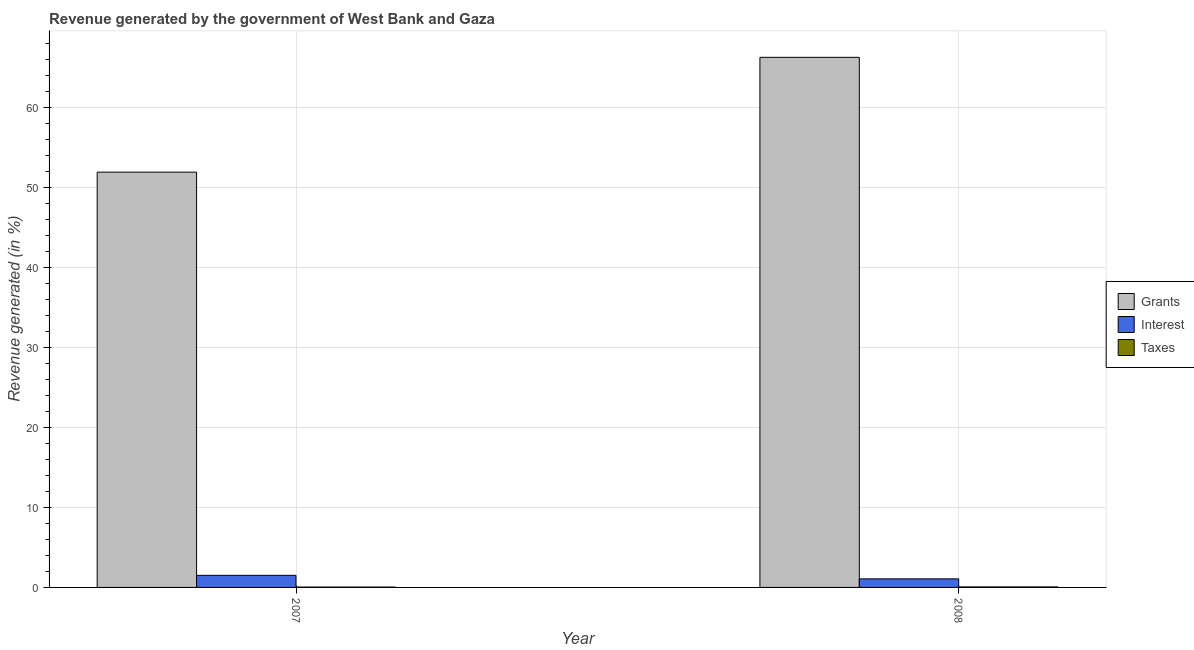How many different coloured bars are there?
Keep it short and to the point. 3. How many bars are there on the 2nd tick from the left?
Your answer should be very brief. 3. What is the label of the 2nd group of bars from the left?
Keep it short and to the point. 2008. What is the percentage of revenue generated by grants in 2008?
Provide a short and direct response. 66.31. Across all years, what is the maximum percentage of revenue generated by taxes?
Your answer should be very brief. 0.06. Across all years, what is the minimum percentage of revenue generated by grants?
Your response must be concise. 51.95. What is the total percentage of revenue generated by grants in the graph?
Offer a terse response. 118.26. What is the difference between the percentage of revenue generated by interest in 2007 and that in 2008?
Offer a very short reply. 0.44. What is the difference between the percentage of revenue generated by taxes in 2007 and the percentage of revenue generated by interest in 2008?
Provide a succinct answer. -0.02. What is the average percentage of revenue generated by taxes per year?
Make the answer very short. 0.05. What is the ratio of the percentage of revenue generated by taxes in 2007 to that in 2008?
Keep it short and to the point. 0.75. Is the percentage of revenue generated by interest in 2007 less than that in 2008?
Your answer should be compact. No. In how many years, is the percentage of revenue generated by interest greater than the average percentage of revenue generated by interest taken over all years?
Keep it short and to the point. 1. What does the 1st bar from the left in 2007 represents?
Offer a terse response. Grants. What does the 1st bar from the right in 2007 represents?
Make the answer very short. Taxes. Is it the case that in every year, the sum of the percentage of revenue generated by grants and percentage of revenue generated by interest is greater than the percentage of revenue generated by taxes?
Provide a short and direct response. Yes. Are all the bars in the graph horizontal?
Provide a short and direct response. No. How many years are there in the graph?
Offer a very short reply. 2. What is the difference between two consecutive major ticks on the Y-axis?
Keep it short and to the point. 10. Are the values on the major ticks of Y-axis written in scientific E-notation?
Offer a terse response. No. Does the graph contain any zero values?
Your answer should be compact. No. Where does the legend appear in the graph?
Provide a succinct answer. Center right. How are the legend labels stacked?
Your answer should be very brief. Vertical. What is the title of the graph?
Keep it short and to the point. Revenue generated by the government of West Bank and Gaza. What is the label or title of the Y-axis?
Your answer should be compact. Revenue generated (in %). What is the Revenue generated (in %) of Grants in 2007?
Ensure brevity in your answer.  51.95. What is the Revenue generated (in %) of Interest in 2007?
Give a very brief answer. 1.51. What is the Revenue generated (in %) in Taxes in 2007?
Your answer should be very brief. 0.05. What is the Revenue generated (in %) in Grants in 2008?
Offer a terse response. 66.31. What is the Revenue generated (in %) of Interest in 2008?
Offer a very short reply. 1.07. What is the Revenue generated (in %) in Taxes in 2008?
Your answer should be compact. 0.06. Across all years, what is the maximum Revenue generated (in %) in Grants?
Give a very brief answer. 66.31. Across all years, what is the maximum Revenue generated (in %) in Interest?
Provide a short and direct response. 1.51. Across all years, what is the maximum Revenue generated (in %) of Taxes?
Your response must be concise. 0.06. Across all years, what is the minimum Revenue generated (in %) of Grants?
Keep it short and to the point. 51.95. Across all years, what is the minimum Revenue generated (in %) of Interest?
Your answer should be very brief. 1.07. Across all years, what is the minimum Revenue generated (in %) of Taxes?
Give a very brief answer. 0.05. What is the total Revenue generated (in %) of Grants in the graph?
Keep it short and to the point. 118.26. What is the total Revenue generated (in %) in Interest in the graph?
Offer a very short reply. 2.59. What is the total Revenue generated (in %) of Taxes in the graph?
Offer a terse response. 0.11. What is the difference between the Revenue generated (in %) of Grants in 2007 and that in 2008?
Provide a succinct answer. -14.36. What is the difference between the Revenue generated (in %) in Interest in 2007 and that in 2008?
Your answer should be very brief. 0.44. What is the difference between the Revenue generated (in %) of Taxes in 2007 and that in 2008?
Provide a short and direct response. -0.02. What is the difference between the Revenue generated (in %) of Grants in 2007 and the Revenue generated (in %) of Interest in 2008?
Keep it short and to the point. 50.88. What is the difference between the Revenue generated (in %) in Grants in 2007 and the Revenue generated (in %) in Taxes in 2008?
Offer a terse response. 51.89. What is the difference between the Revenue generated (in %) of Interest in 2007 and the Revenue generated (in %) of Taxes in 2008?
Provide a short and direct response. 1.45. What is the average Revenue generated (in %) in Grants per year?
Give a very brief answer. 59.13. What is the average Revenue generated (in %) in Interest per year?
Your answer should be compact. 1.29. What is the average Revenue generated (in %) in Taxes per year?
Provide a succinct answer. 0.05. In the year 2007, what is the difference between the Revenue generated (in %) in Grants and Revenue generated (in %) in Interest?
Your answer should be very brief. 50.44. In the year 2007, what is the difference between the Revenue generated (in %) of Grants and Revenue generated (in %) of Taxes?
Offer a terse response. 51.9. In the year 2007, what is the difference between the Revenue generated (in %) of Interest and Revenue generated (in %) of Taxes?
Offer a very short reply. 1.47. In the year 2008, what is the difference between the Revenue generated (in %) of Grants and Revenue generated (in %) of Interest?
Provide a short and direct response. 65.24. In the year 2008, what is the difference between the Revenue generated (in %) of Grants and Revenue generated (in %) of Taxes?
Keep it short and to the point. 66.25. In the year 2008, what is the difference between the Revenue generated (in %) of Interest and Revenue generated (in %) of Taxes?
Your response must be concise. 1.01. What is the ratio of the Revenue generated (in %) of Grants in 2007 to that in 2008?
Provide a short and direct response. 0.78. What is the ratio of the Revenue generated (in %) in Interest in 2007 to that in 2008?
Your answer should be compact. 1.41. What is the ratio of the Revenue generated (in %) in Taxes in 2007 to that in 2008?
Offer a terse response. 0.75. What is the difference between the highest and the second highest Revenue generated (in %) in Grants?
Give a very brief answer. 14.36. What is the difference between the highest and the second highest Revenue generated (in %) in Interest?
Your answer should be compact. 0.44. What is the difference between the highest and the second highest Revenue generated (in %) of Taxes?
Your response must be concise. 0.02. What is the difference between the highest and the lowest Revenue generated (in %) of Grants?
Give a very brief answer. 14.36. What is the difference between the highest and the lowest Revenue generated (in %) in Interest?
Ensure brevity in your answer.  0.44. What is the difference between the highest and the lowest Revenue generated (in %) of Taxes?
Ensure brevity in your answer.  0.02. 